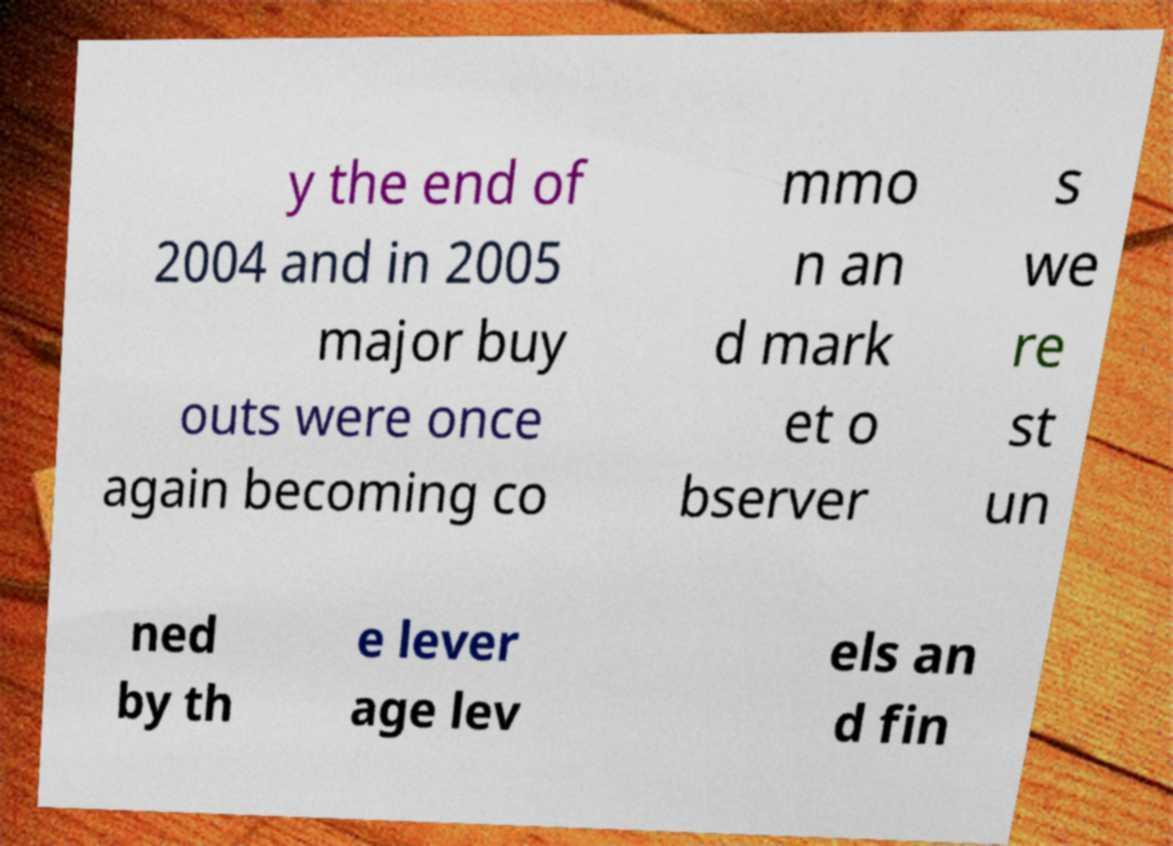What messages or text are displayed in this image? I need them in a readable, typed format. y the end of 2004 and in 2005 major buy outs were once again becoming co mmo n an d mark et o bserver s we re st un ned by th e lever age lev els an d fin 